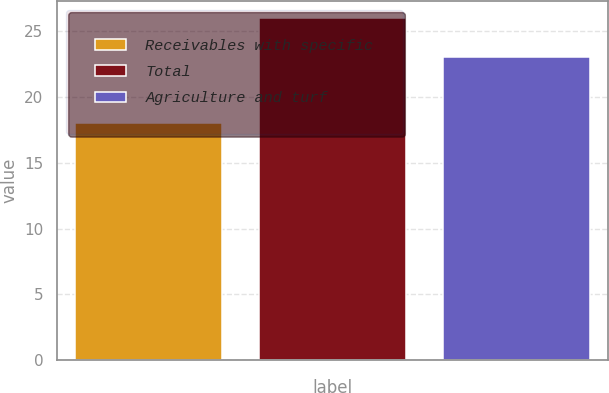Convert chart. <chart><loc_0><loc_0><loc_500><loc_500><bar_chart><fcel>Receivables with specific<fcel>Total<fcel>Agriculture and turf<nl><fcel>18<fcel>26<fcel>23<nl></chart> 